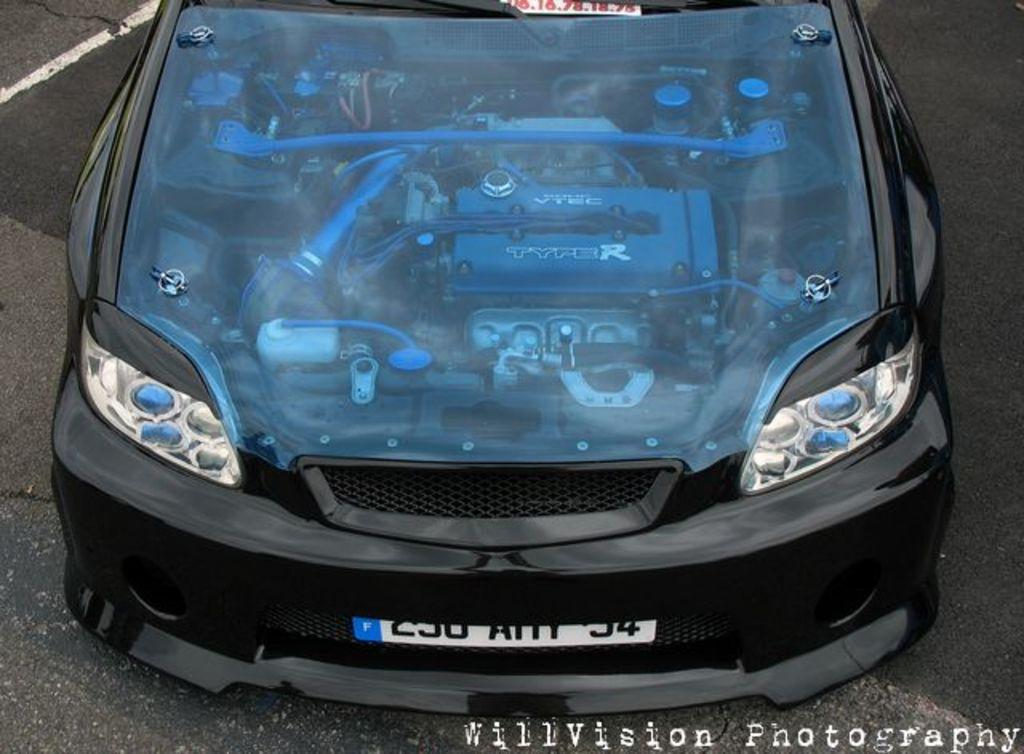What type of vehicle is in the image? There is a black car in the image. What part of the car can be seen in the image? The engine of the car is visible. What is present in the bottom right corner of the image? There is a watermark in the bottom right corner of the image. What can be seen on the right side of the image? There is a road on the right side of the image. Is there a volcano erupting in the background of the image? No, there is no volcano present in the image. 